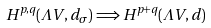Convert formula to latex. <formula><loc_0><loc_0><loc_500><loc_500>H ^ { p , q } ( \Lambda V , d _ { \sigma } ) \Longrightarrow H ^ { p + q } ( \Lambda V , d )</formula> 